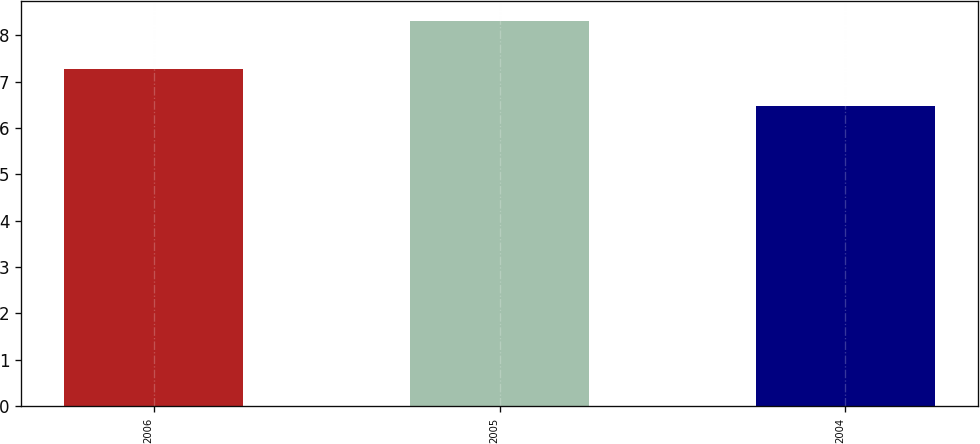<chart> <loc_0><loc_0><loc_500><loc_500><bar_chart><fcel>2006<fcel>2005<fcel>2004<nl><fcel>7.28<fcel>8.32<fcel>6.48<nl></chart> 